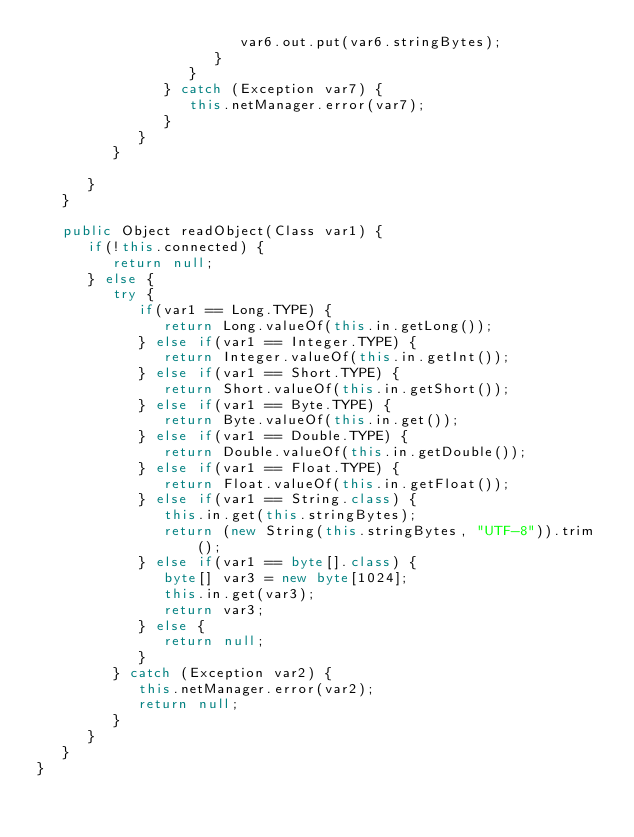Convert code to text. <code><loc_0><loc_0><loc_500><loc_500><_Java_>                        var6.out.put(var6.stringBytes);
                     }
                  }
               } catch (Exception var7) {
                  this.netManager.error(var7);
               }
            }
         }

      }
   }

   public Object readObject(Class var1) {
      if(!this.connected) {
         return null;
      } else {
         try {
            if(var1 == Long.TYPE) {
               return Long.valueOf(this.in.getLong());
            } else if(var1 == Integer.TYPE) {
               return Integer.valueOf(this.in.getInt());
            } else if(var1 == Short.TYPE) {
               return Short.valueOf(this.in.getShort());
            } else if(var1 == Byte.TYPE) {
               return Byte.valueOf(this.in.get());
            } else if(var1 == Double.TYPE) {
               return Double.valueOf(this.in.getDouble());
            } else if(var1 == Float.TYPE) {
               return Float.valueOf(this.in.getFloat());
            } else if(var1 == String.class) {
               this.in.get(this.stringBytes);
               return (new String(this.stringBytes, "UTF-8")).trim();
            } else if(var1 == byte[].class) {
               byte[] var3 = new byte[1024];
               this.in.get(var3);
               return var3;
            } else {
               return null;
            }
         } catch (Exception var2) {
            this.netManager.error(var2);
            return null;
         }
      }
   }
}
</code> 